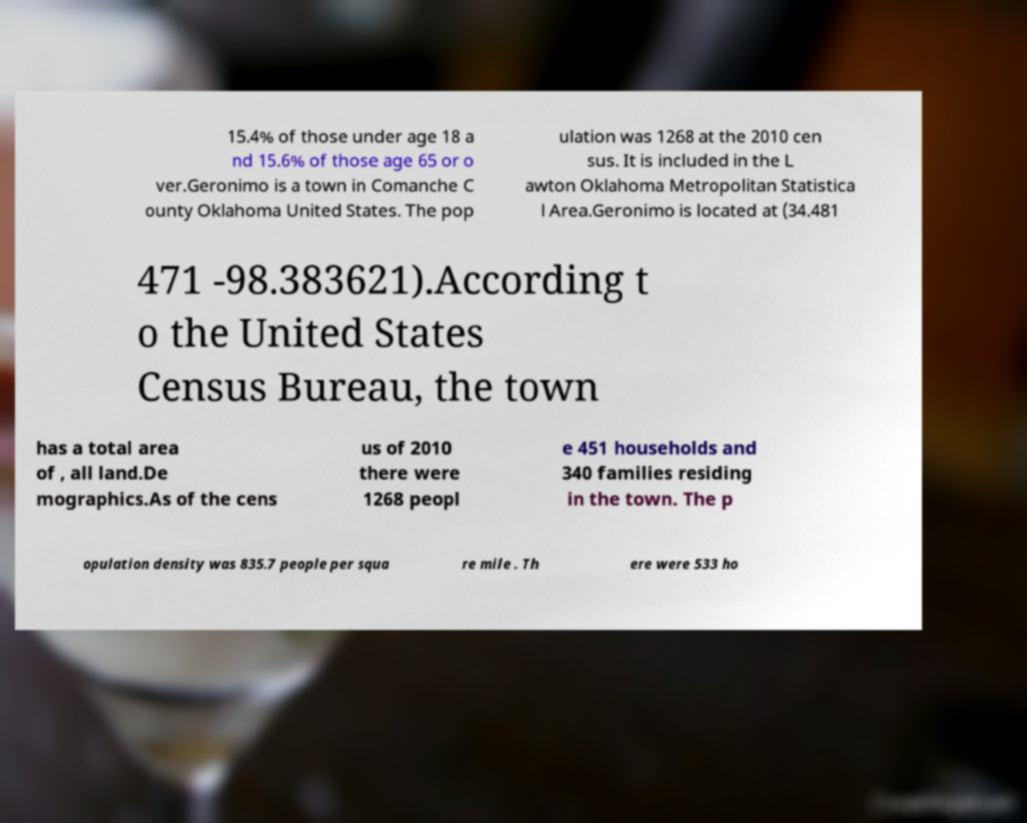What messages or text are displayed in this image? I need them in a readable, typed format. 15.4% of those under age 18 a nd 15.6% of those age 65 or o ver.Geronimo is a town in Comanche C ounty Oklahoma United States. The pop ulation was 1268 at the 2010 cen sus. It is included in the L awton Oklahoma Metropolitan Statistica l Area.Geronimo is located at (34.481 471 -98.383621).According t o the United States Census Bureau, the town has a total area of , all land.De mographics.As of the cens us of 2010 there were 1268 peopl e 451 households and 340 families residing in the town. The p opulation density was 835.7 people per squa re mile . Th ere were 533 ho 